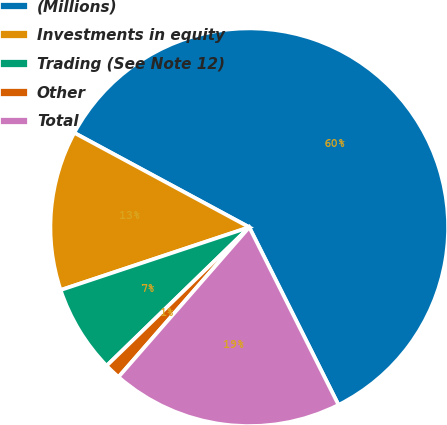Convert chart. <chart><loc_0><loc_0><loc_500><loc_500><pie_chart><fcel>(Millions)<fcel>Investments in equity<fcel>Trading (See Note 12)<fcel>Other<fcel>Total<nl><fcel>59.71%<fcel>12.99%<fcel>7.15%<fcel>1.31%<fcel>18.83%<nl></chart> 